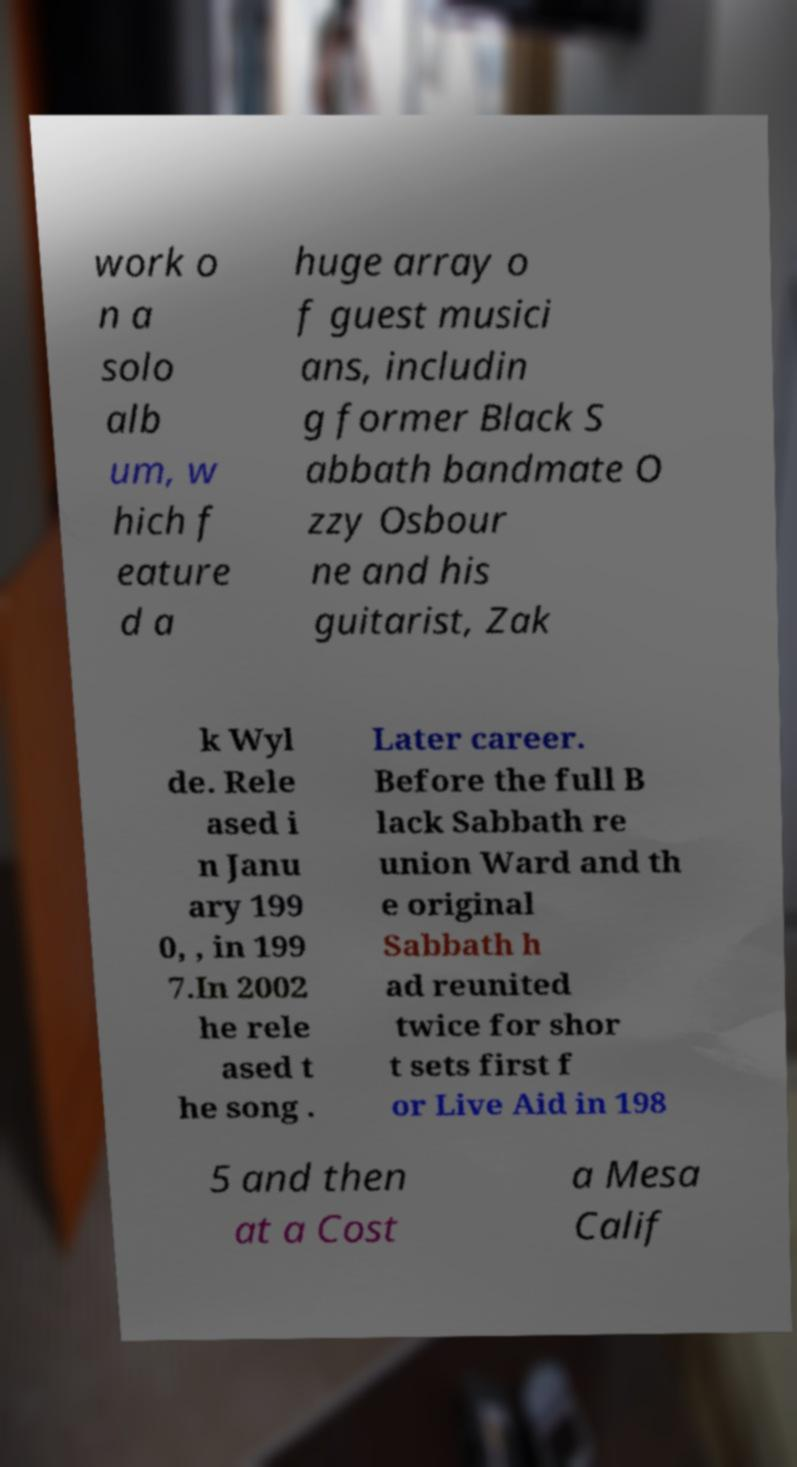What messages or text are displayed in this image? I need them in a readable, typed format. work o n a solo alb um, w hich f eature d a huge array o f guest musici ans, includin g former Black S abbath bandmate O zzy Osbour ne and his guitarist, Zak k Wyl de. Rele ased i n Janu ary 199 0, , in 199 7.In 2002 he rele ased t he song . Later career. Before the full B lack Sabbath re union Ward and th e original Sabbath h ad reunited twice for shor t sets first f or Live Aid in 198 5 and then at a Cost a Mesa Calif 